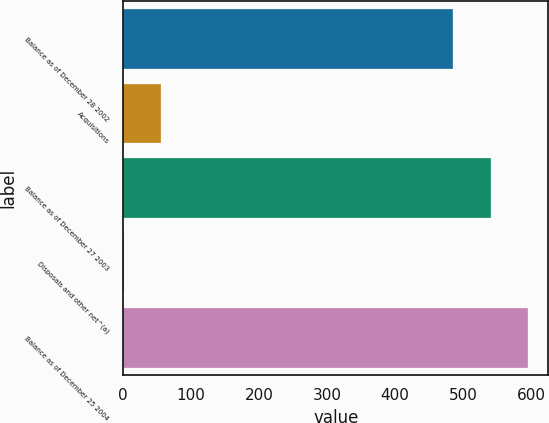Convert chart. <chart><loc_0><loc_0><loc_500><loc_500><bar_chart><fcel>Balance as of December 28 2002<fcel>Acquisitions<fcel>Balance as of December 27 2003<fcel>Disposals and other net^(a)<fcel>Balance as of December 25 2004<nl><fcel>485<fcel>56.2<fcel>540.2<fcel>1<fcel>595.4<nl></chart> 